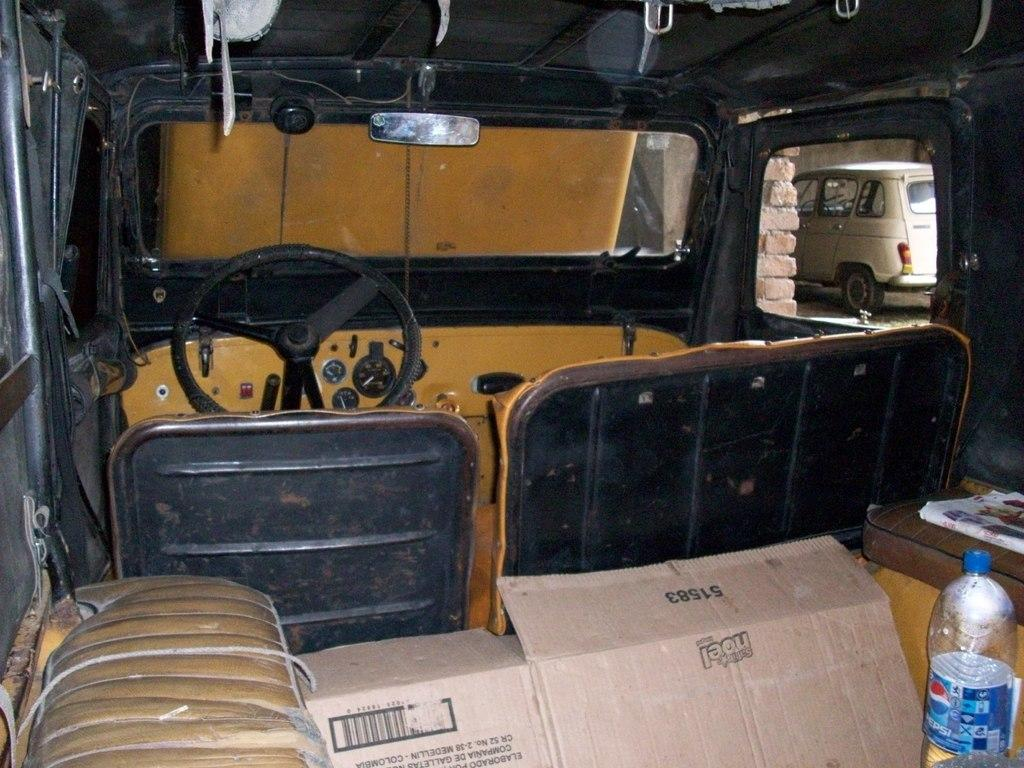What type of location is depicted in the image? The image is an inside view of a vehicle. What is a key component of the vehicle's interior? There is a steering wheel in the vehicle. What is provided for the driver or passengers to sit on? There is a seat in the vehicle. What is used for the driver to see behind them? There is a mirror in the vehicle. What material is used to provide visibility and protection from the elements? There is glass in the vehicle. What items can be seen inside the vehicle? There is a bottle and cardboard in the vehicle. What can be seen outside the vehicle? There is a car and bricks visible outside the vehicle. What type of wave can be seen crashing against the car outside the vehicle? There is no wave present in the image; it depicts a car and bricks visible outside the vehicle. What type of ice can be seen melting on the seat inside the vehicle? There is no ice present in the image; it shows a bottle and cardboard inside the vehicle. 